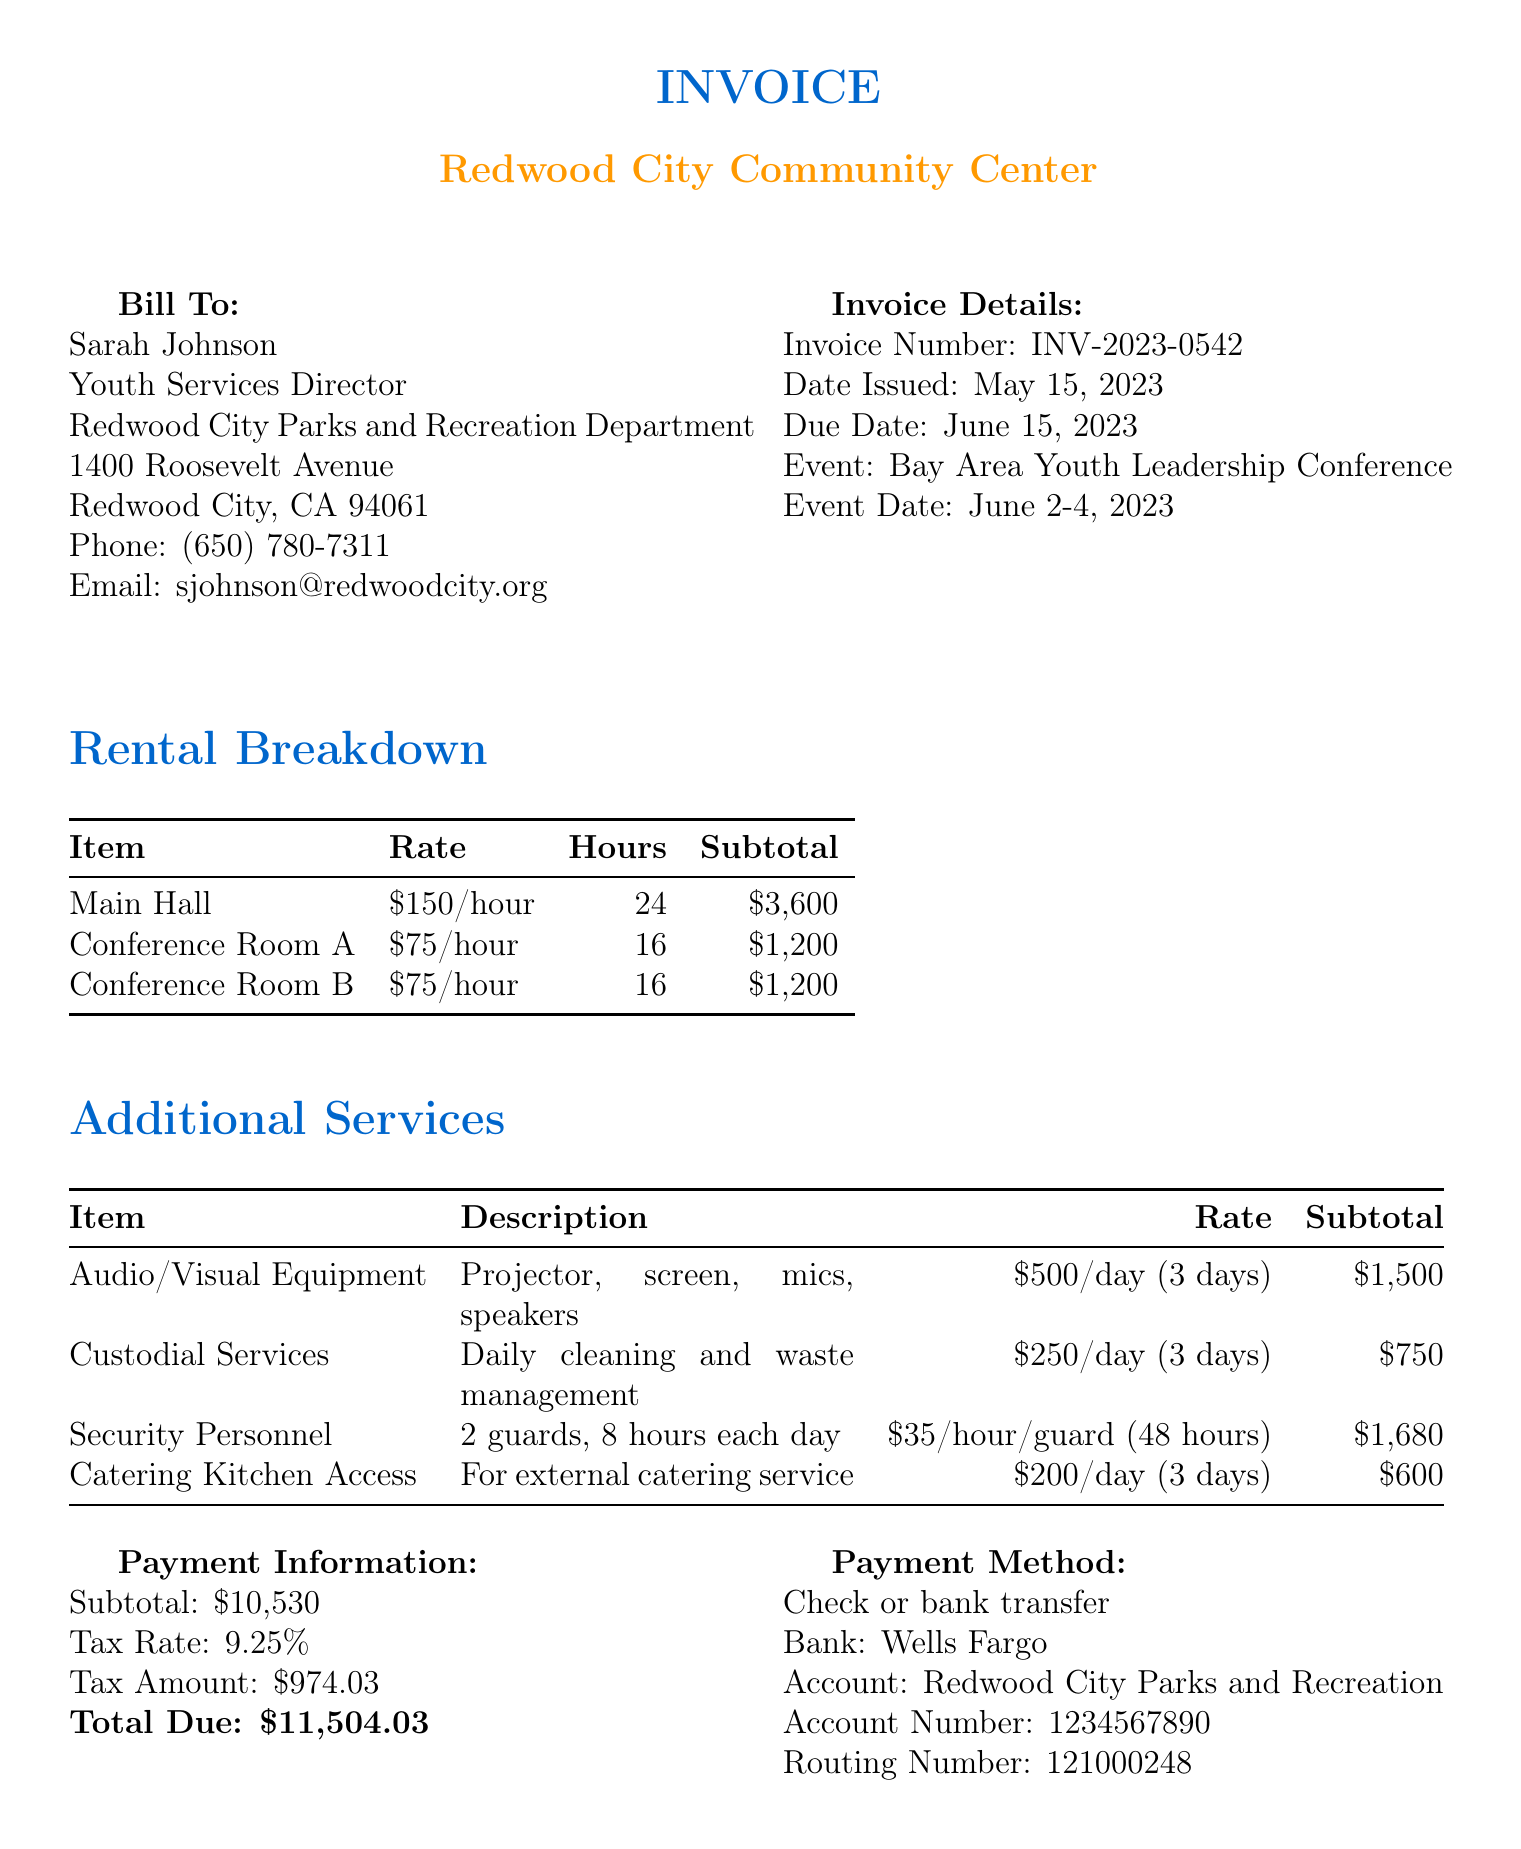what is the invoice number? The invoice number is listed in the document under Invoice Details.
Answer: INV-2023-0542 who is the client? The client's name and title are stated at the beginning of the document.
Answer: Sarah Johnson what is the total due amount? The total due is clearly stated in the Payment Information section of the document.
Answer: $11,504.03 how many hours was the Main Hall rented? The number of hours for the Main Hall rental is specified in the Rental Breakdown section.
Answer: 24 what is the rate for Security Personnel? The rate for Security Personnel can be found in the Additional Services section.
Answer: $35 per hour per guard what is the tax amount? The tax amount is provided under the Payment Information section.
Answer: $974.03 how many days was the Audio/Visual Equipment rented? The duration of the rental for the Audio/Visual Equipment is mentioned in the Additional Services section.
Answer: 3 days what is the cancellation fee percentage? The cancellation fee is stated in the Terms and Conditions section of the document.
Answer: 50% who should payments be made to? The account name for payments is listed in the Payment Method section.
Answer: Redwood City Parks and Recreation 